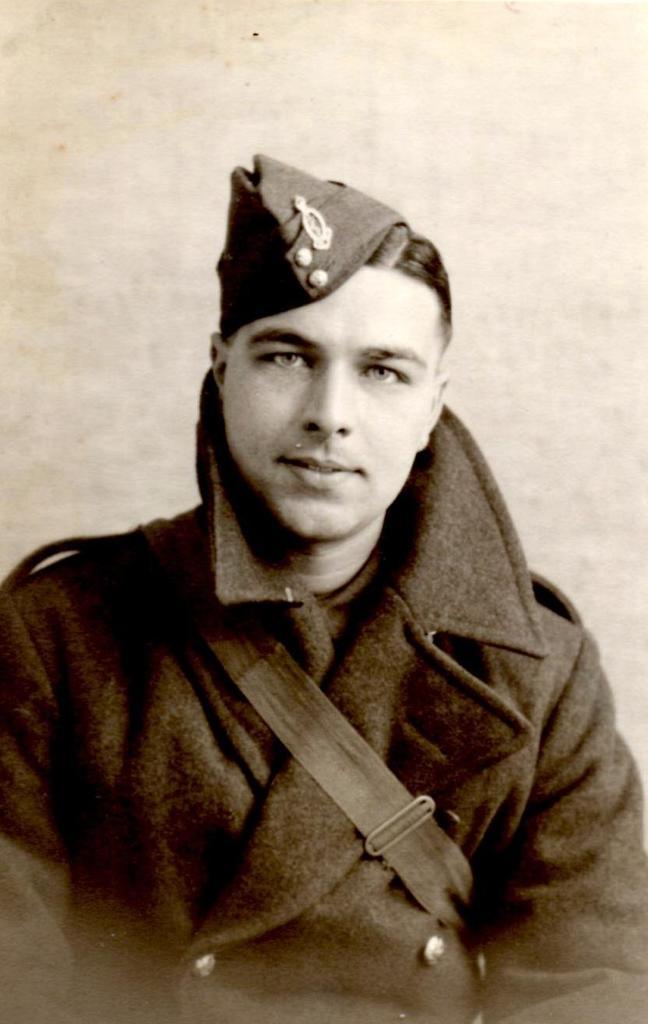How would you summarize this image in a sentence or two? This is a close up image of a person wearing clothes and cap and the background is white. 